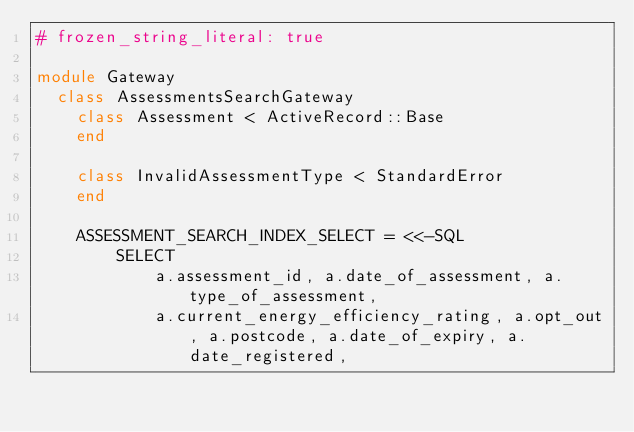Convert code to text. <code><loc_0><loc_0><loc_500><loc_500><_Ruby_># frozen_string_literal: true

module Gateway
  class AssessmentsSearchGateway
    class Assessment < ActiveRecord::Base
    end

    class InvalidAssessmentType < StandardError
    end

    ASSESSMENT_SEARCH_INDEX_SELECT = <<-SQL
        SELECT
            a.assessment_id, a.date_of_assessment, a.type_of_assessment,
            a.current_energy_efficiency_rating, a.opt_out, a.postcode, a.date_of_expiry, a.date_registered,</code> 